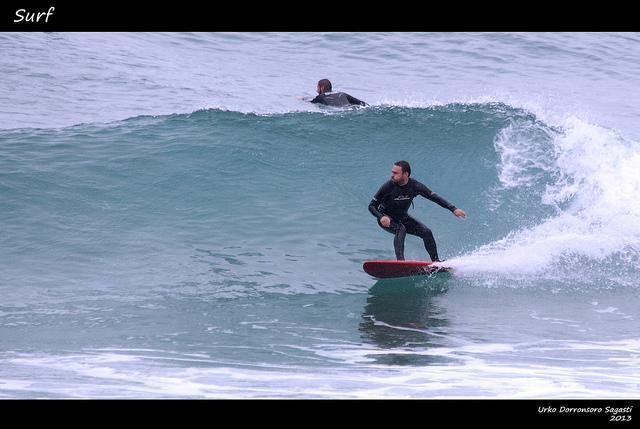How many cows are there?
Give a very brief answer. 0. 